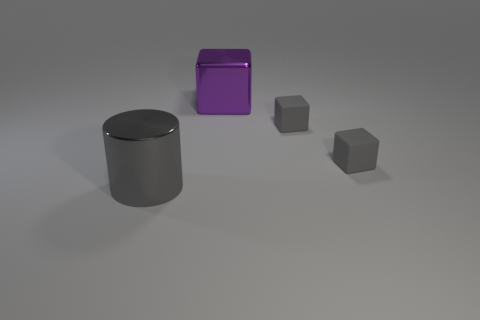Add 3 shiny blocks. How many objects exist? 7 Subtract all cylinders. How many objects are left? 3 Subtract 0 brown cubes. How many objects are left? 4 Subtract all small objects. Subtract all rubber blocks. How many objects are left? 0 Add 4 big purple objects. How many big purple objects are left? 5 Add 2 small shiny blocks. How many small shiny blocks exist? 2 